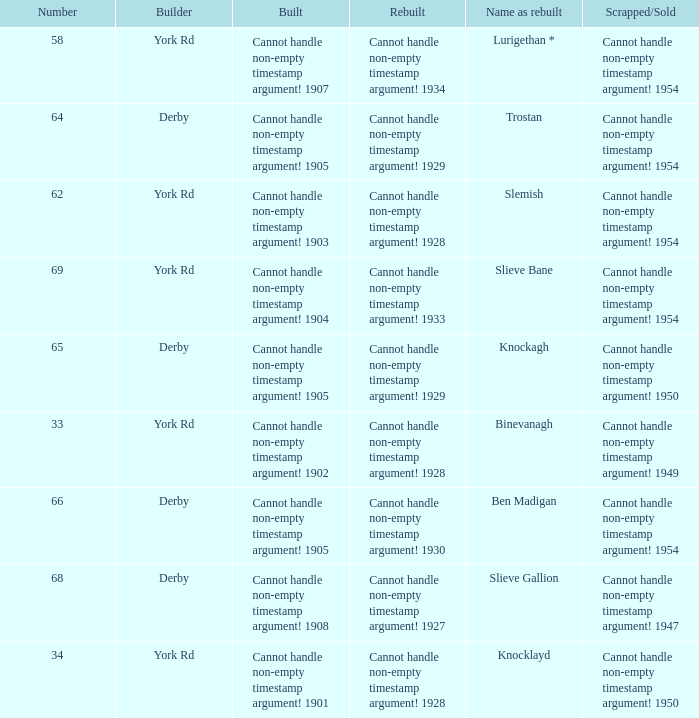Which Scrapped/Sold has a Builder of derby, and a Name as rebuilt of ben madigan? Cannot handle non-empty timestamp argument! 1954. 